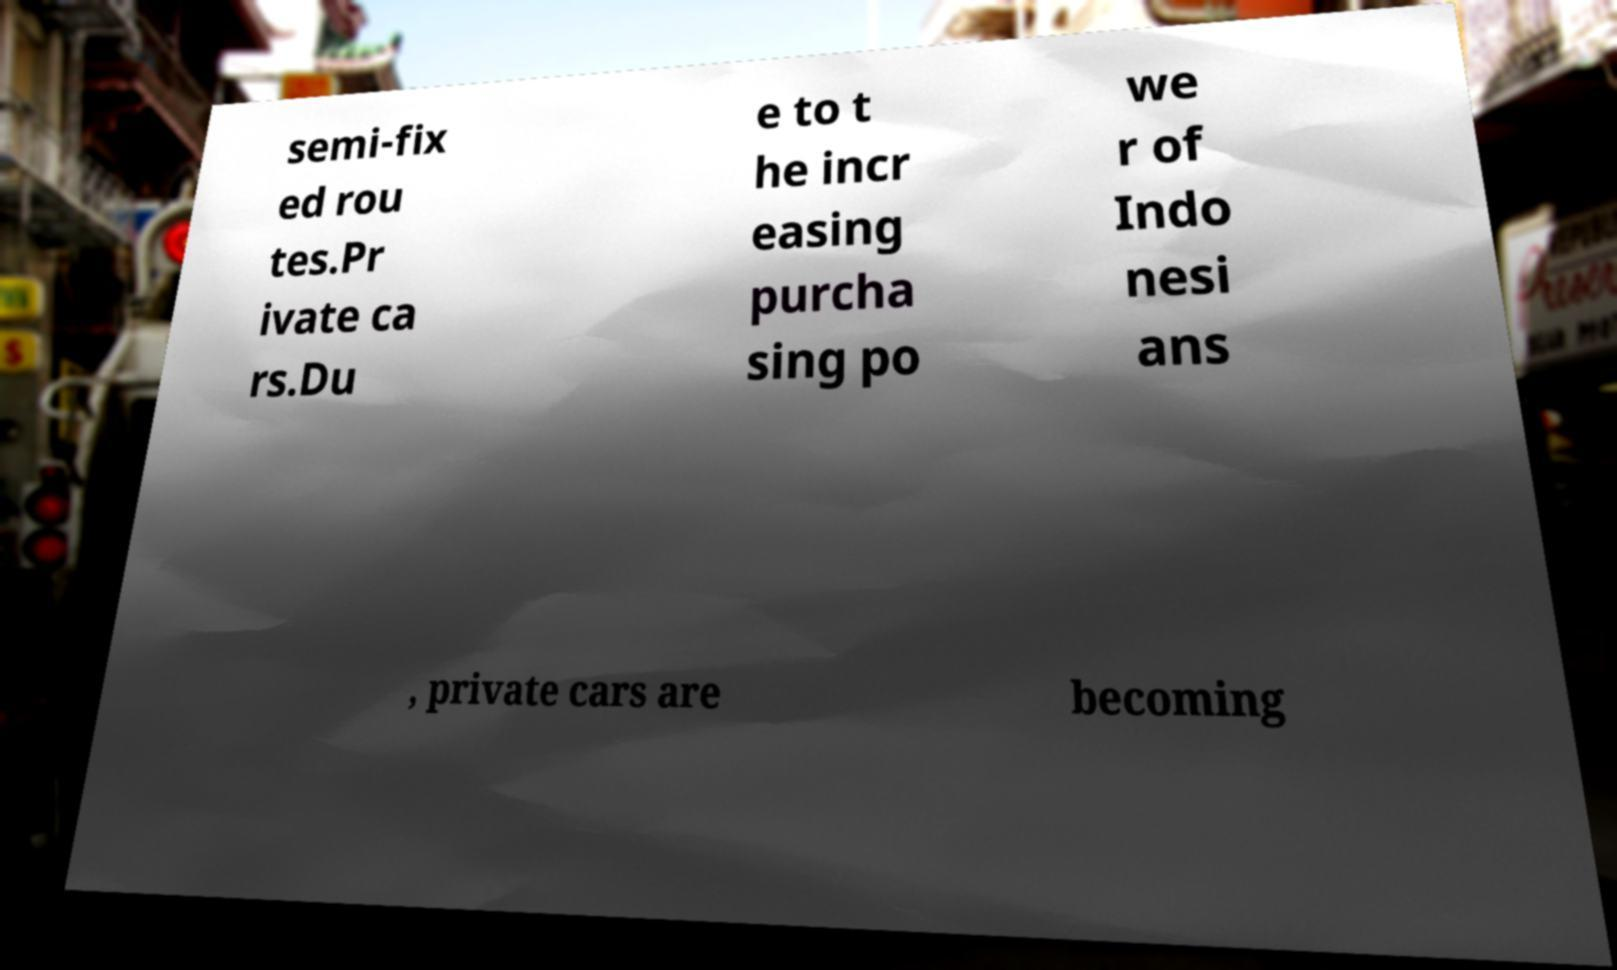Please identify and transcribe the text found in this image. semi-fix ed rou tes.Pr ivate ca rs.Du e to t he incr easing purcha sing po we r of Indo nesi ans , private cars are becoming 